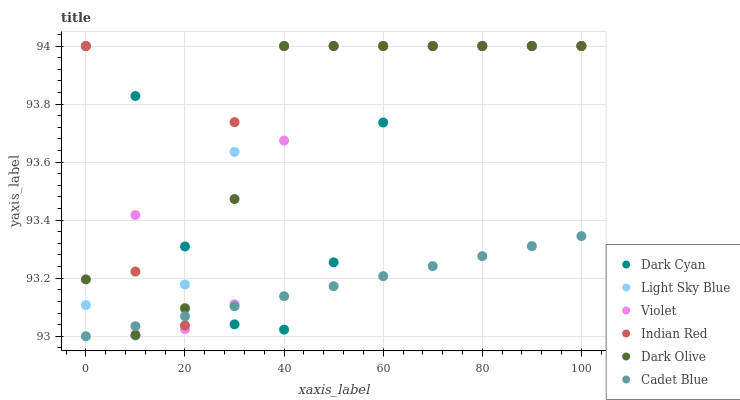Does Cadet Blue have the minimum area under the curve?
Answer yes or no. Yes. Does Indian Red have the maximum area under the curve?
Answer yes or no. Yes. Does Dark Olive have the minimum area under the curve?
Answer yes or no. No. Does Dark Olive have the maximum area under the curve?
Answer yes or no. No. Is Cadet Blue the smoothest?
Answer yes or no. Yes. Is Indian Red the roughest?
Answer yes or no. Yes. Is Dark Olive the smoothest?
Answer yes or no. No. Is Dark Olive the roughest?
Answer yes or no. No. Does Cadet Blue have the lowest value?
Answer yes or no. Yes. Does Dark Olive have the lowest value?
Answer yes or no. No. Does Dark Cyan have the highest value?
Answer yes or no. Yes. Does Indian Red intersect Violet?
Answer yes or no. Yes. Is Indian Red less than Violet?
Answer yes or no. No. Is Indian Red greater than Violet?
Answer yes or no. No. 